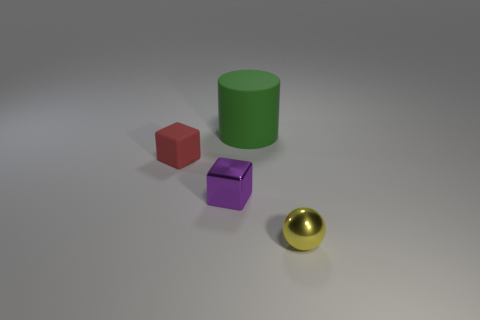Subtract all red cubes. How many cubes are left? 1 Subtract 1 blocks. How many blocks are left? 1 Add 4 small brown objects. How many objects exist? 8 Subtract all cylinders. How many objects are left? 3 Subtract all yellow cylinders. How many green balls are left? 0 Subtract 0 red cylinders. How many objects are left? 4 Subtract all purple balls. Subtract all gray cylinders. How many balls are left? 1 Subtract all purple things. Subtract all tiny things. How many objects are left? 0 Add 1 big green rubber things. How many big green rubber things are left? 2 Add 2 large gray metallic objects. How many large gray metallic objects exist? 2 